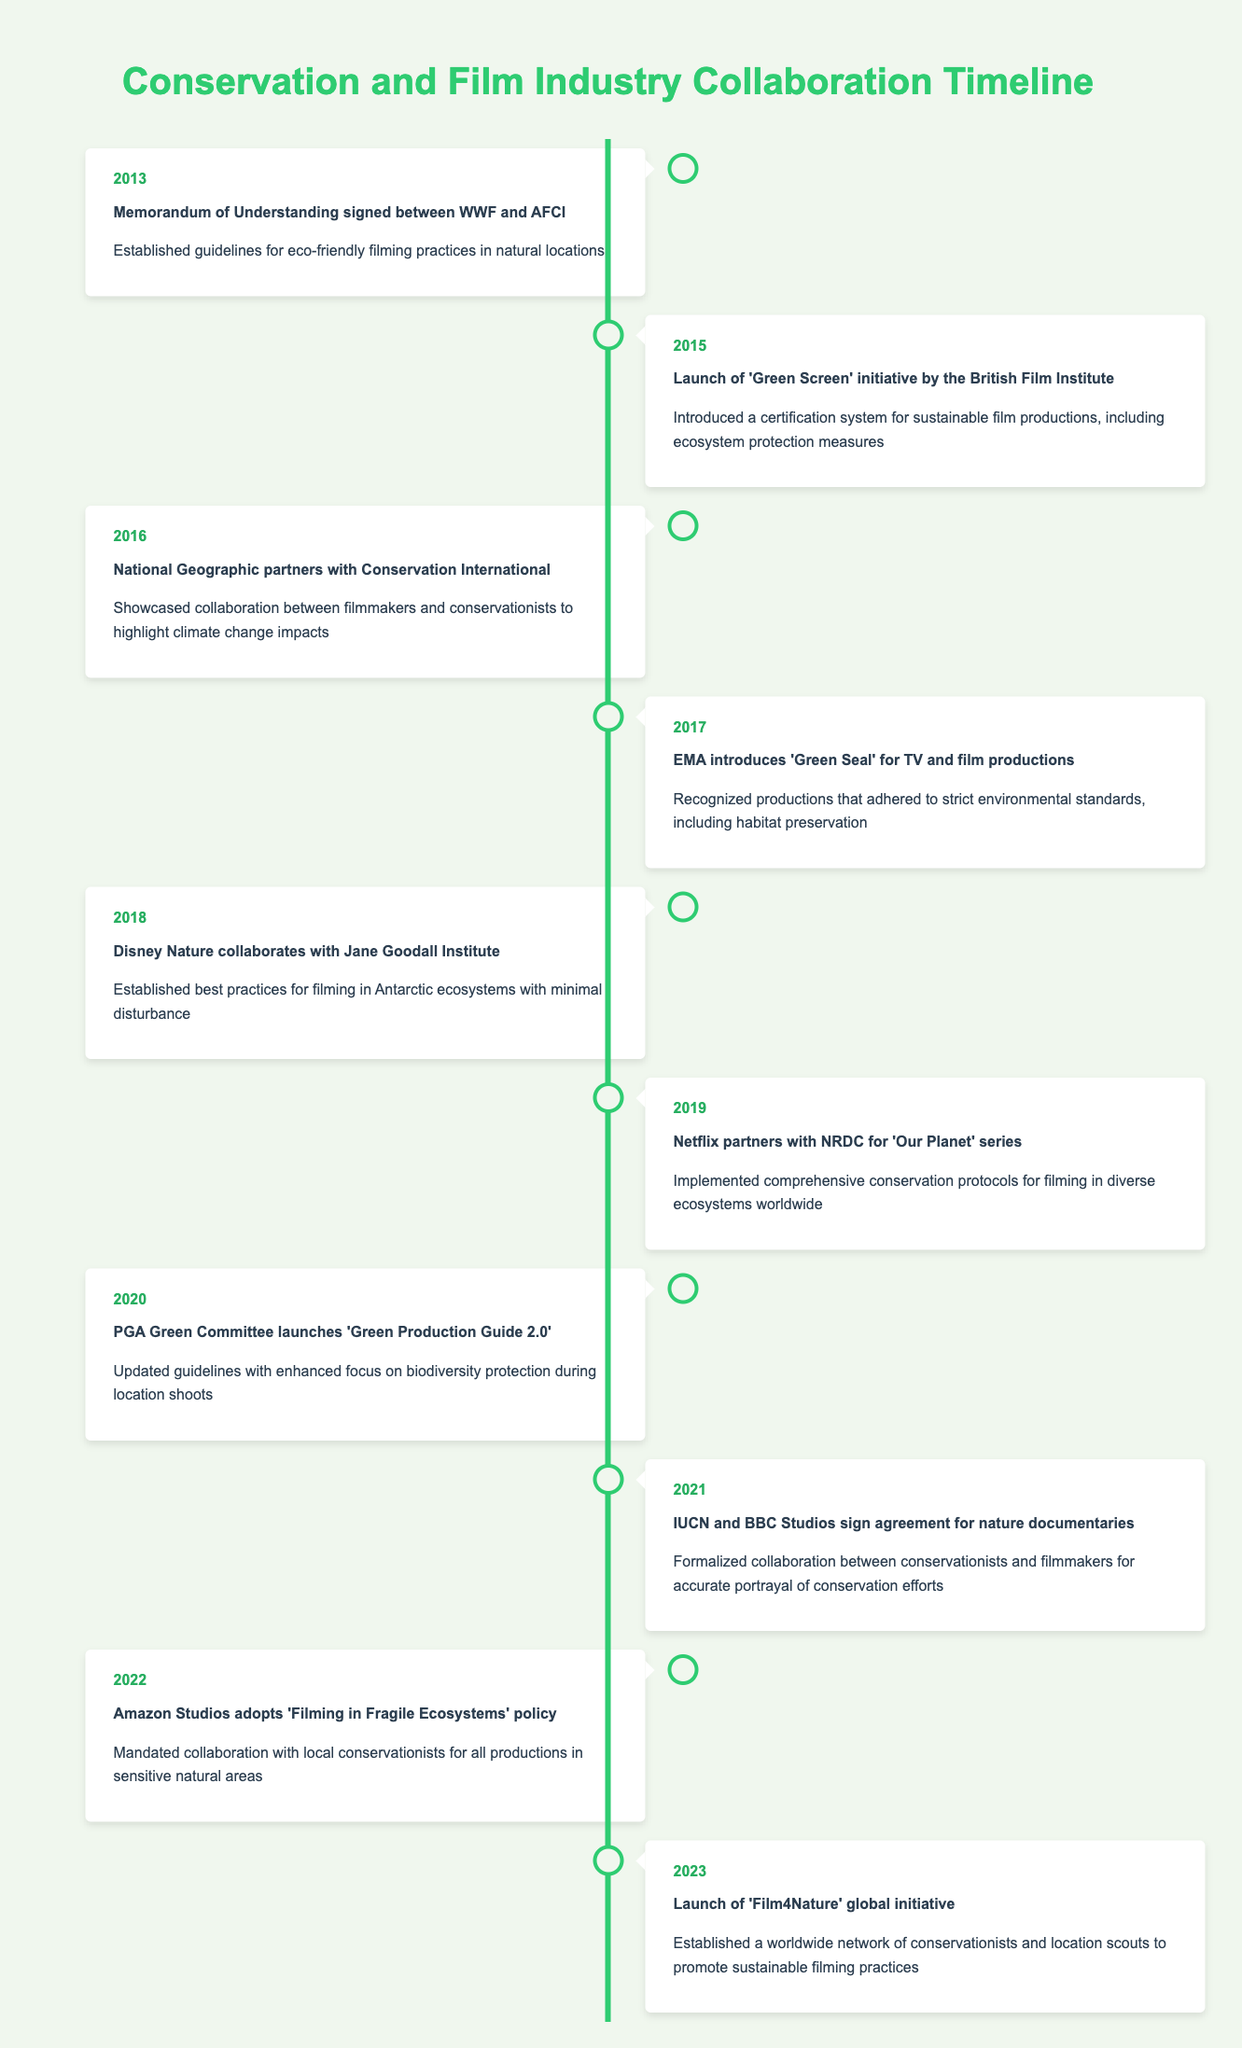What year did the 'Green Screen' initiative launch? The 'Green Screen' initiative was launched by the British Film Institute in 2015. This can be easily found in the timeline under the year 2015.
Answer: 2015 What is the main focus of the 2020 'Green Production Guide 2.0'? The 2020 'Green Production Guide 2.0' focused on biodiversity protection during location shoots, as stated in the event description for that year.
Answer: Biodiversity protection Which event occurred first, the signing of the memorandum between WWF and AFCI or the introduction of the 'Green Seal' by the EMA? The signing of the memorandum between WWF and AFCI occurred in 2013, while the 'Green Seal' was introduced by the EMA in 2017. Therefore, the first event is the memorandum signing.
Answer: Memorandum of Understanding How many collaborations between conservationists and filmmakers occurred from 2018 to 2023? The collaborations between 2018 and 2023 include: Disney Nature and Jane Goodall Institute (2018), Netflix and NRDC (2019), IUCN and BBC Studios (2021), Amazon Studios policy (2022), and 'Film4Nature' initiative (2023). This totals to five collaborations.
Answer: 5 Did any of the events between 2013 and 2023 involve the National Geographic? Yes, the National Geographic partnered with Conservation International for the 'Years of Living Dangerously' series in 2016, as indicated in the timeline.
Answer: Yes What was the main outcome of the collaboration between Disney Nature and the Jane Goodall Institute? The main outcome was the establishment of best practices for filming in Antarctic ecosystems with minimal disturbance, which is specifically mentioned in the 2018 entry.
Answer: Best practices for Antarctic filming In which year did the most recent initiative, 'Film4Nature', get launched? The most recent initiative, 'Film4Nature', was launched in 2023, as that is the last event listed in the timeline data.
Answer: 2023 What can be concluded about the trend in collaboration over the years between 2013 and 2023? The trend shows a clear increase in formal agreements, initiatives, and policies aimed at promoting eco-friendly filming practices and collaboration with conservationists, with more partnerships forming as the timeline progresses.
Answer: Increased collaboration 